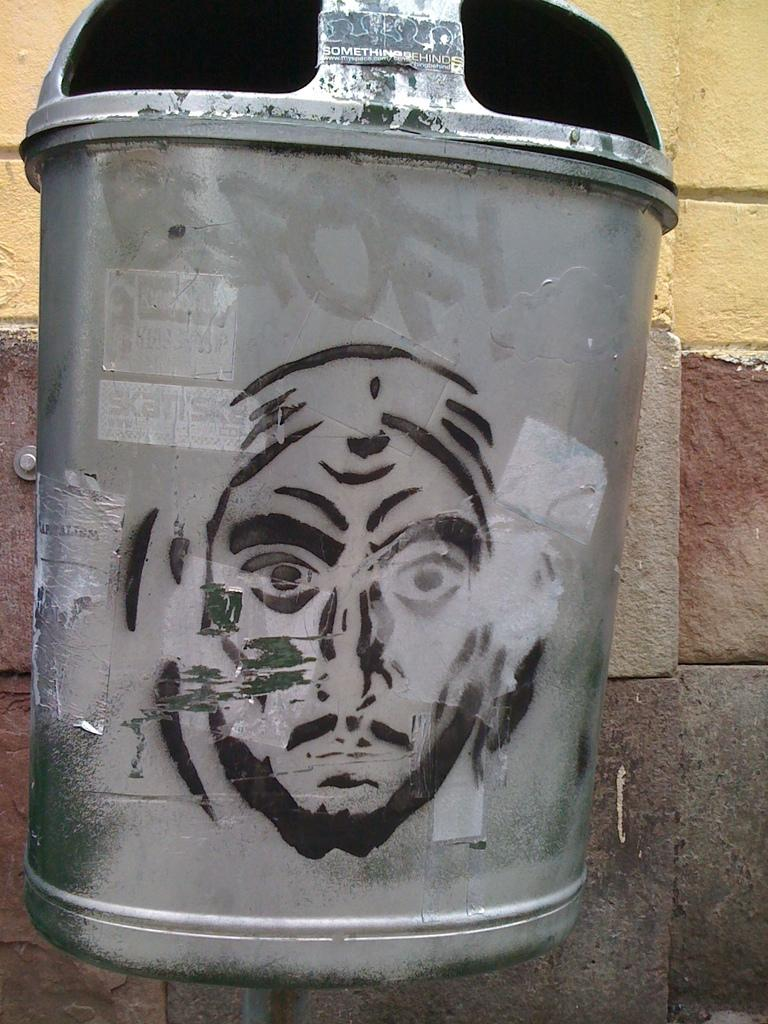What object is present in the image that is typically used for waste disposal? There is a trash can in the image. What unique feature can be seen on the trash can? The face of a person is painted on the trash can. What type of structure can be seen in the background of the image? There is a stone wall in the background of the image. Where is the cart located in the image? There is no cart present in the image. What type of rat can be seen interacting with the trash can in the image? There are no rats present in the image. 